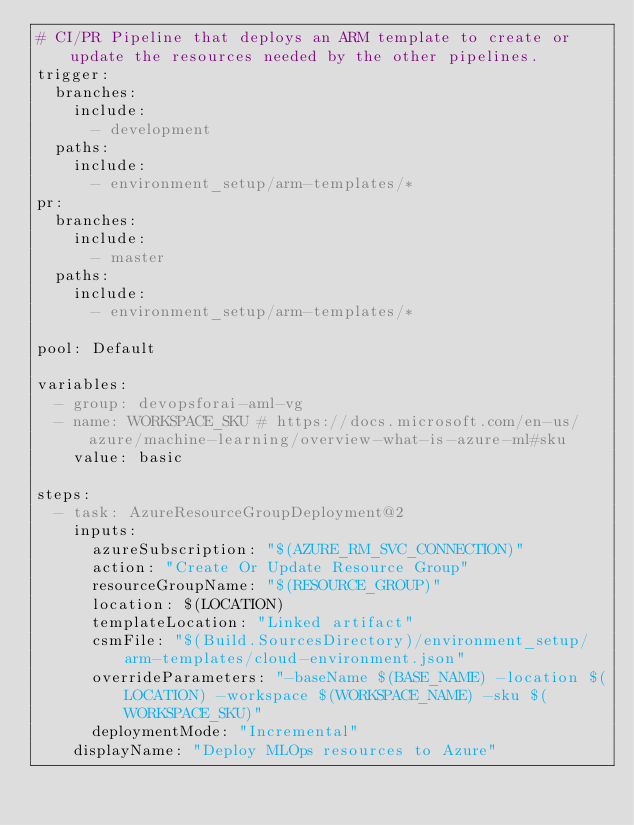Convert code to text. <code><loc_0><loc_0><loc_500><loc_500><_YAML_># CI/PR Pipeline that deploys an ARM template to create or update the resources needed by the other pipelines.
trigger:
  branches:
    include:
      - development
  paths:
    include:
      - environment_setup/arm-templates/*
pr:
  branches:
    include:
      - master
  paths:
    include:
      - environment_setup/arm-templates/*

pool: Default

variables:
  - group: devopsforai-aml-vg
  - name: WORKSPACE_SKU # https://docs.microsoft.com/en-us/azure/machine-learning/overview-what-is-azure-ml#sku
    value: basic

steps:
  - task: AzureResourceGroupDeployment@2
    inputs:
      azureSubscription: "$(AZURE_RM_SVC_CONNECTION)"
      action: "Create Or Update Resource Group"
      resourceGroupName: "$(RESOURCE_GROUP)"
      location: $(LOCATION)
      templateLocation: "Linked artifact"
      csmFile: "$(Build.SourcesDirectory)/environment_setup/arm-templates/cloud-environment.json"
      overrideParameters: "-baseName $(BASE_NAME) -location $(LOCATION) -workspace $(WORKSPACE_NAME) -sku $(WORKSPACE_SKU)"
      deploymentMode: "Incremental"
    displayName: "Deploy MLOps resources to Azure"
</code> 